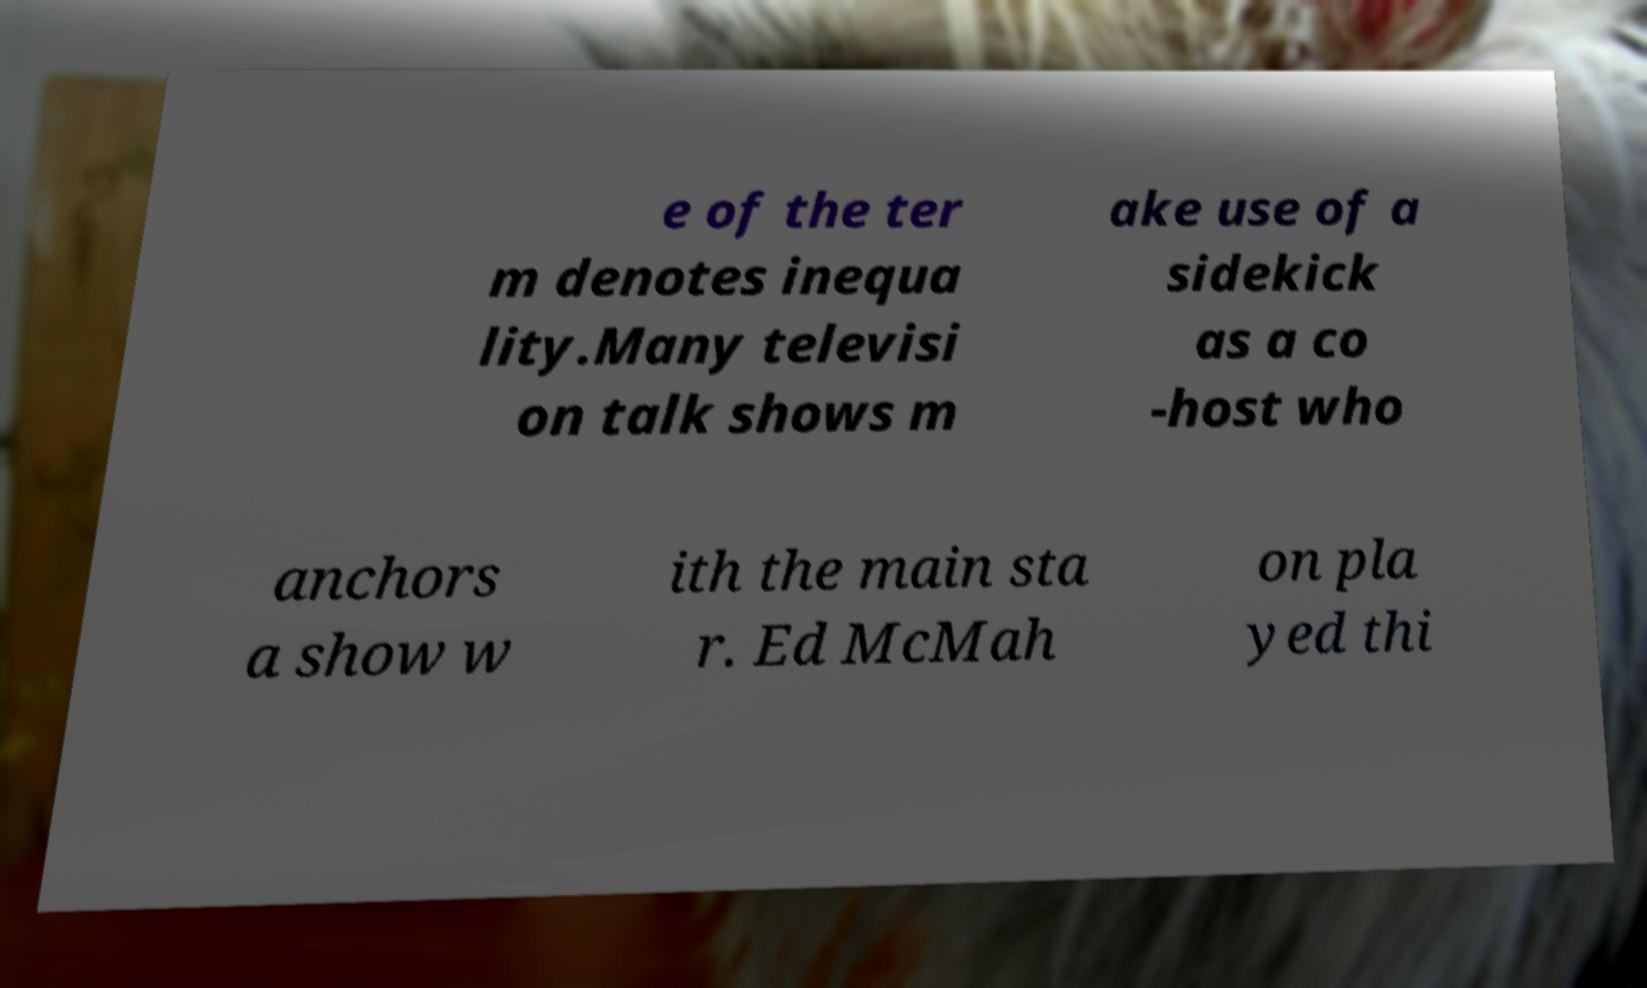Could you extract and type out the text from this image? e of the ter m denotes inequa lity.Many televisi on talk shows m ake use of a sidekick as a co -host who anchors a show w ith the main sta r. Ed McMah on pla yed thi 